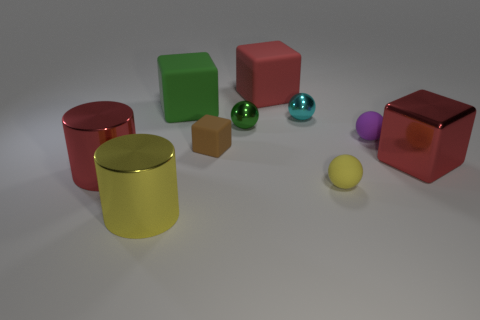Subtract all cyan cubes. Subtract all cyan spheres. How many cubes are left? 4 Subtract all cubes. How many objects are left? 6 Subtract all small gray metallic things. Subtract all small cyan balls. How many objects are left? 9 Add 1 red cylinders. How many red cylinders are left? 2 Add 8 tiny brown things. How many tiny brown things exist? 9 Subtract 0 gray cubes. How many objects are left? 10 